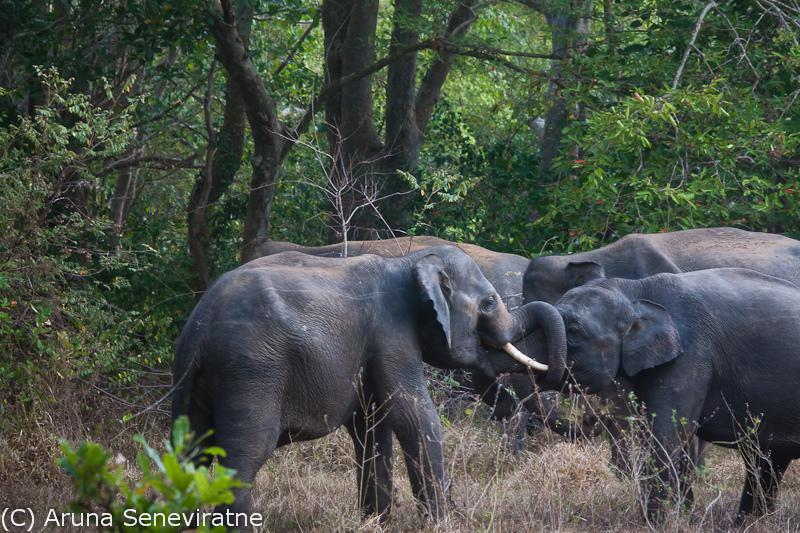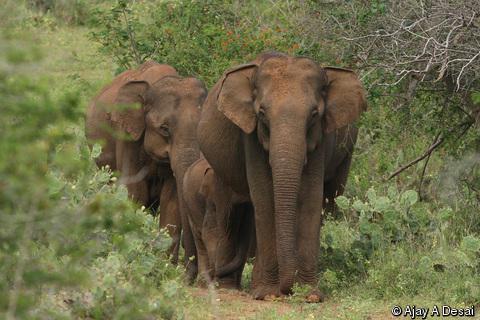The first image is the image on the left, the second image is the image on the right. Analyze the images presented: Is the assertion "An image features just one elephant, which has large tusks." valid? Answer yes or no. No. 